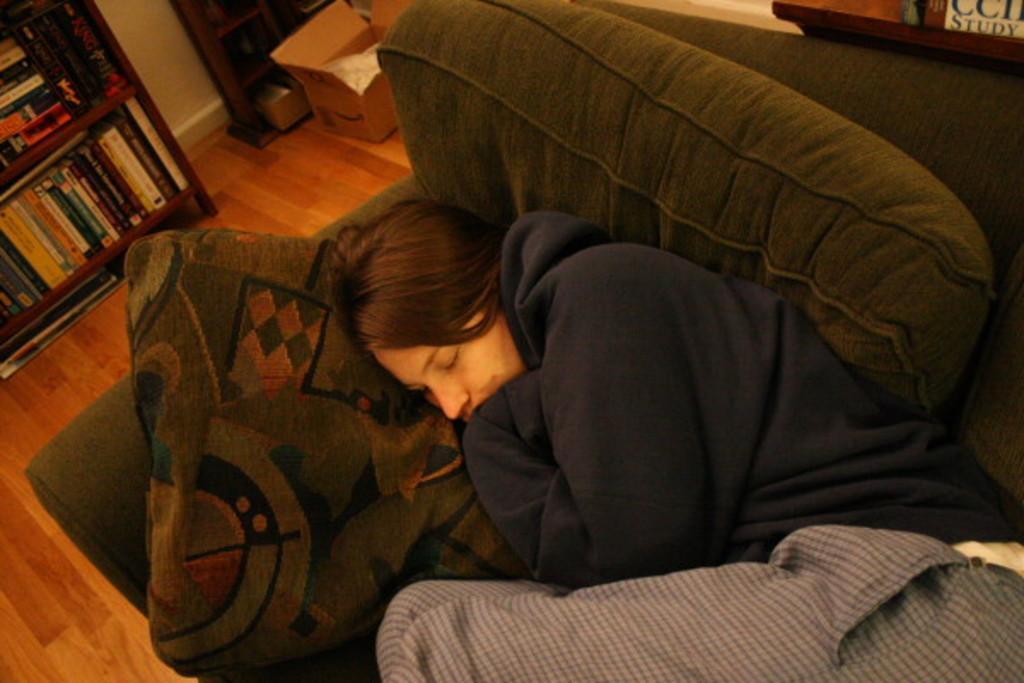Can you describe this image briefly? In this image we can see a girl sleeping on a couch wearing a jacket. In the background of the image there is a bookshelf. At the bottom of the image there is a wooden floor. There is a box. 